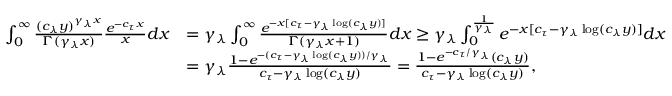Convert formula to latex. <formula><loc_0><loc_0><loc_500><loc_500>\begin{array} { r l } { \int _ { 0 } ^ { \infty } \frac { ( c _ { \lambda } y ) ^ { \gamma _ { \lambda } x } } { \Gamma ( \gamma _ { \lambda } x ) } \frac { e ^ { - c _ { \tau } x } } { x } d x } & { = \gamma _ { \lambda } \int _ { 0 } ^ { \infty } \frac { e ^ { - x [ c _ { \tau } - \gamma _ { \lambda } \log ( c _ { \lambda } y ) ] } } { \Gamma ( \gamma _ { \lambda } x + 1 ) } d x \geq \gamma _ { \lambda } \int _ { 0 } ^ { \frac { 1 } { \gamma _ { \lambda } } } e ^ { - x [ c _ { \tau } - \gamma _ { \lambda } \log ( c _ { \lambda } y ) ] } d x } \\ & { = \gamma _ { \lambda } \frac { 1 - e ^ { - ( c _ { \tau } - \gamma _ { \lambda } \log ( c _ { \lambda } y ) ) / { \gamma _ { \lambda } } } } { c _ { \tau } - \gamma _ { \lambda } \log ( c _ { \lambda } y ) } = \frac { 1 - e ^ { - c _ { \tau } / \gamma _ { \lambda } } ( c _ { \lambda } y ) } { c _ { \tau } - \gamma _ { \lambda } \log ( c _ { \lambda } y ) } , } \end{array}</formula> 